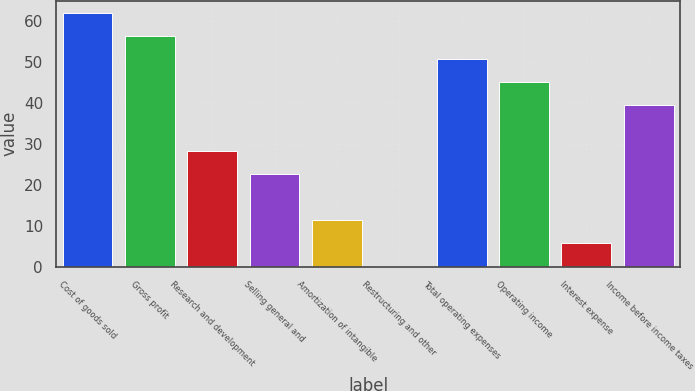Convert chart to OTSL. <chart><loc_0><loc_0><loc_500><loc_500><bar_chart><fcel>Cost of goods sold<fcel>Gross profit<fcel>Research and development<fcel>Selling general and<fcel>Amortization of intangible<fcel>Restructuring and other<fcel>Total operating expenses<fcel>Operating income<fcel>Interest expense<fcel>Income before income taxes<nl><fcel>61.92<fcel>56.3<fcel>28.2<fcel>22.58<fcel>11.34<fcel>0.1<fcel>50.68<fcel>45.06<fcel>5.72<fcel>39.44<nl></chart> 